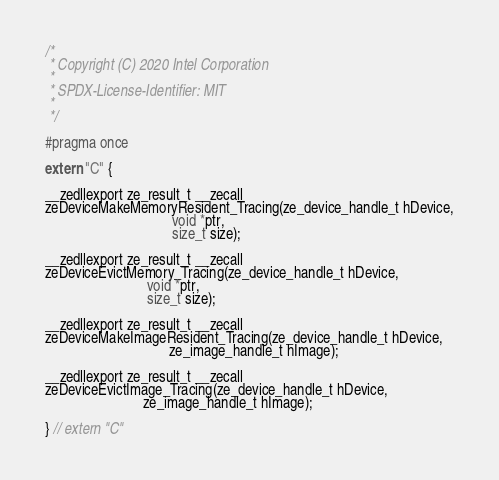Convert code to text. <code><loc_0><loc_0><loc_500><loc_500><_C_>/*
 * Copyright (C) 2020 Intel Corporation
 *
 * SPDX-License-Identifier: MIT
 *
 */

#pragma once

extern "C" {

__zedllexport ze_result_t __zecall
zeDeviceMakeMemoryResident_Tracing(ze_device_handle_t hDevice,
                                   void *ptr,
                                   size_t size);

__zedllexport ze_result_t __zecall
zeDeviceEvictMemory_Tracing(ze_device_handle_t hDevice,
                            void *ptr,
                            size_t size);

__zedllexport ze_result_t __zecall
zeDeviceMakeImageResident_Tracing(ze_device_handle_t hDevice,
                                  ze_image_handle_t hImage);

__zedllexport ze_result_t __zecall
zeDeviceEvictImage_Tracing(ze_device_handle_t hDevice,
                           ze_image_handle_t hImage);

} // extern "C"
</code> 